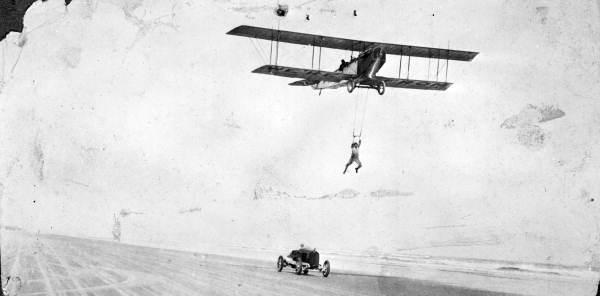How many people are hanging from the plane?
Give a very brief answer. 1. 